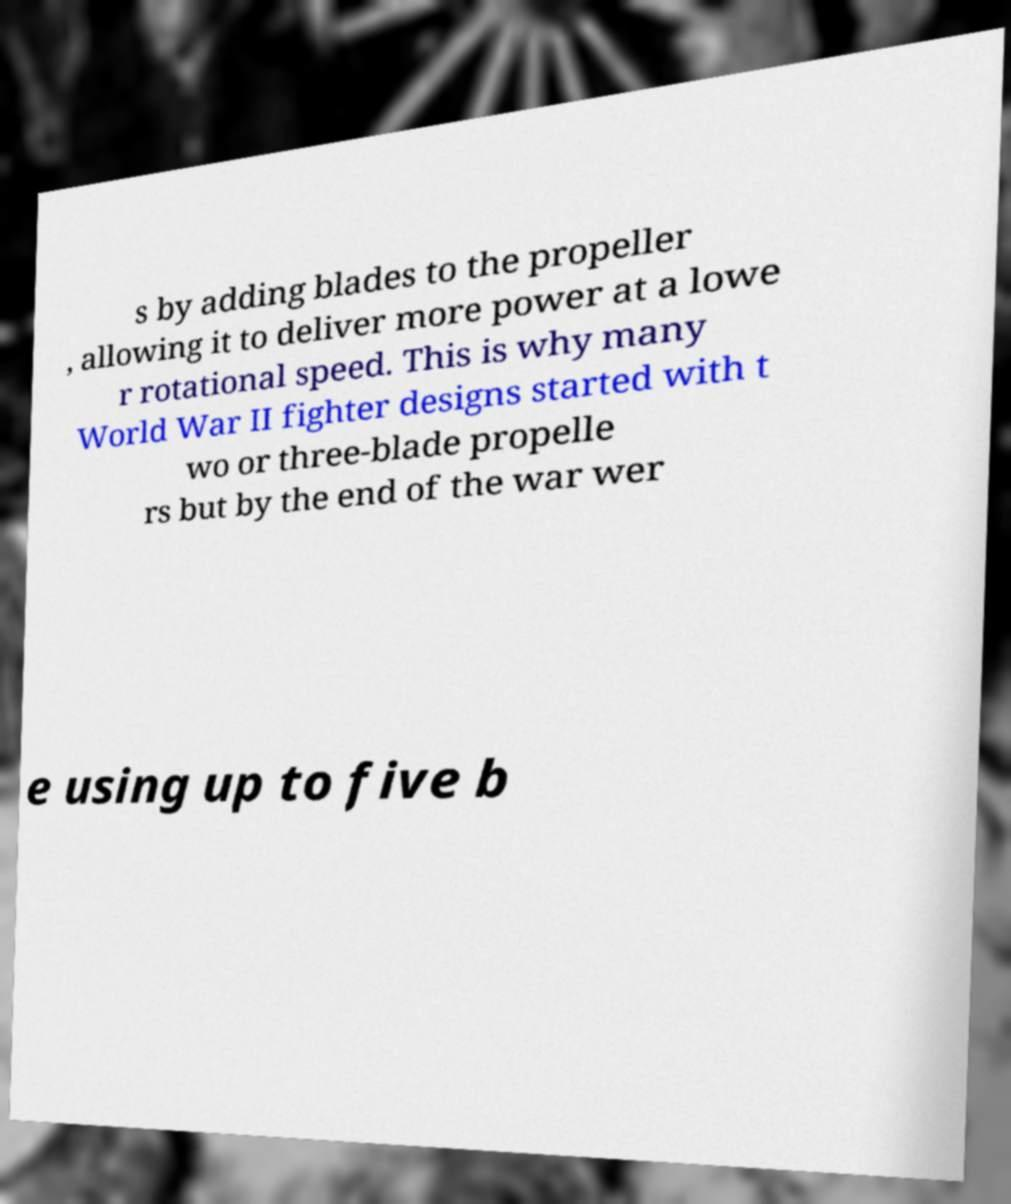Can you accurately transcribe the text from the provided image for me? s by adding blades to the propeller , allowing it to deliver more power at a lowe r rotational speed. This is why many World War II fighter designs started with t wo or three-blade propelle rs but by the end of the war wer e using up to five b 